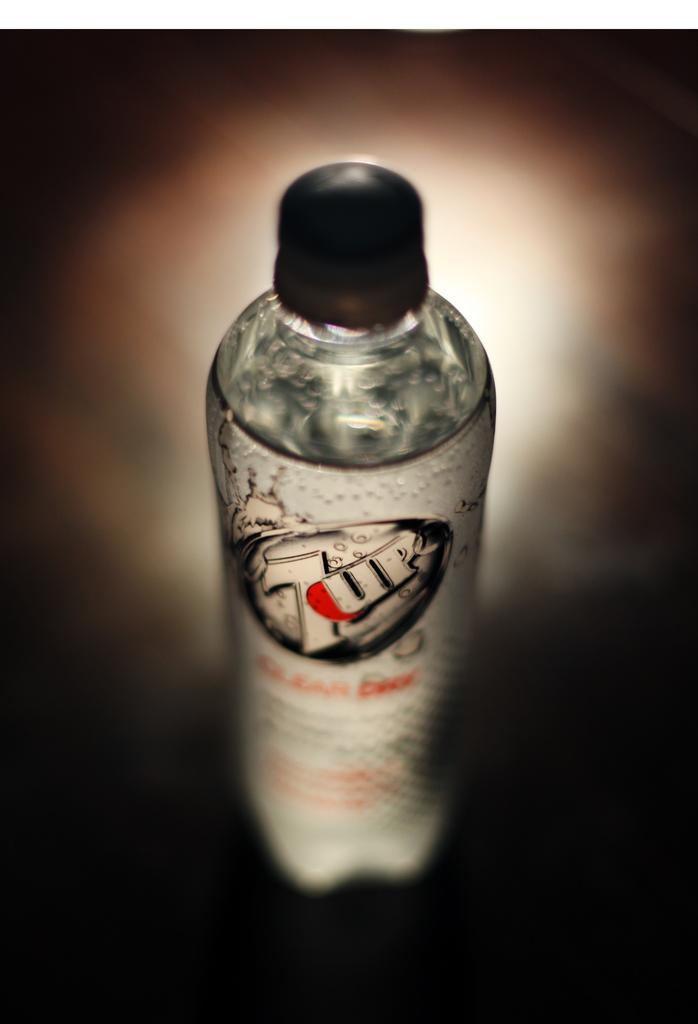What object can be seen in the image? There is a bottle in the image. What is inside the bottle? The bottle is filled with a liquid. How much credit is available on the bottle in the image? There is no mention of credit or any financial aspect related to the bottle in the image. 